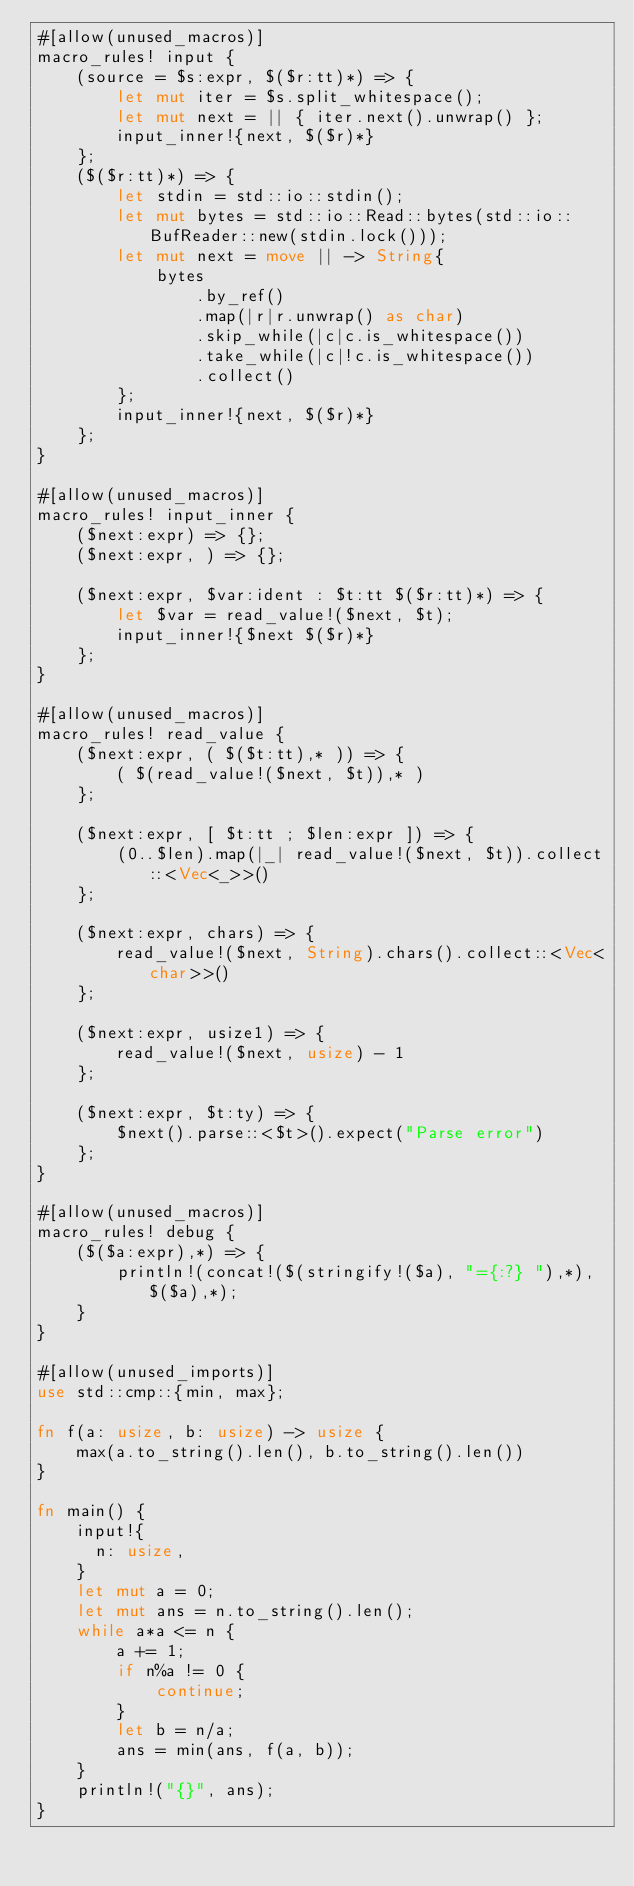<code> <loc_0><loc_0><loc_500><loc_500><_Rust_>#[allow(unused_macros)]
macro_rules! input {
    (source = $s:expr, $($r:tt)*) => {
        let mut iter = $s.split_whitespace();
        let mut next = || { iter.next().unwrap() };
        input_inner!{next, $($r)*}
    };
    ($($r:tt)*) => {
        let stdin = std::io::stdin();
        let mut bytes = std::io::Read::bytes(std::io::BufReader::new(stdin.lock()));
        let mut next = move || -> String{
            bytes
                .by_ref()
                .map(|r|r.unwrap() as char)
                .skip_while(|c|c.is_whitespace())
                .take_while(|c|!c.is_whitespace())
                .collect()
        };
        input_inner!{next, $($r)*}
    };
}

#[allow(unused_macros)]
macro_rules! input_inner {
    ($next:expr) => {};
    ($next:expr, ) => {};

    ($next:expr, $var:ident : $t:tt $($r:tt)*) => {
        let $var = read_value!($next, $t);
        input_inner!{$next $($r)*}
    };
}

#[allow(unused_macros)]
macro_rules! read_value {
    ($next:expr, ( $($t:tt),* )) => {
        ( $(read_value!($next, $t)),* )
    };

    ($next:expr, [ $t:tt ; $len:expr ]) => {
        (0..$len).map(|_| read_value!($next, $t)).collect::<Vec<_>>()
    };

    ($next:expr, chars) => {
        read_value!($next, String).chars().collect::<Vec<char>>()
    };

    ($next:expr, usize1) => {
        read_value!($next, usize) - 1
    };

    ($next:expr, $t:ty) => {
        $next().parse::<$t>().expect("Parse error")
    };
}

#[allow(unused_macros)]
macro_rules! debug {
    ($($a:expr),*) => {
        println!(concat!($(stringify!($a), "={:?} "),*), $($a),*);
    }
}

#[allow(unused_imports)]
use std::cmp::{min, max};

fn f(a: usize, b: usize) -> usize {
    max(a.to_string().len(), b.to_string().len())
}

fn main() {
    input!{
      n: usize,
    }
    let mut a = 0;
    let mut ans = n.to_string().len();
    while a*a <= n {
        a += 1;
        if n%a != 0 {
            continue;
        }
        let b = n/a;
        ans = min(ans, f(a, b));
    }
    println!("{}", ans);
}
</code> 